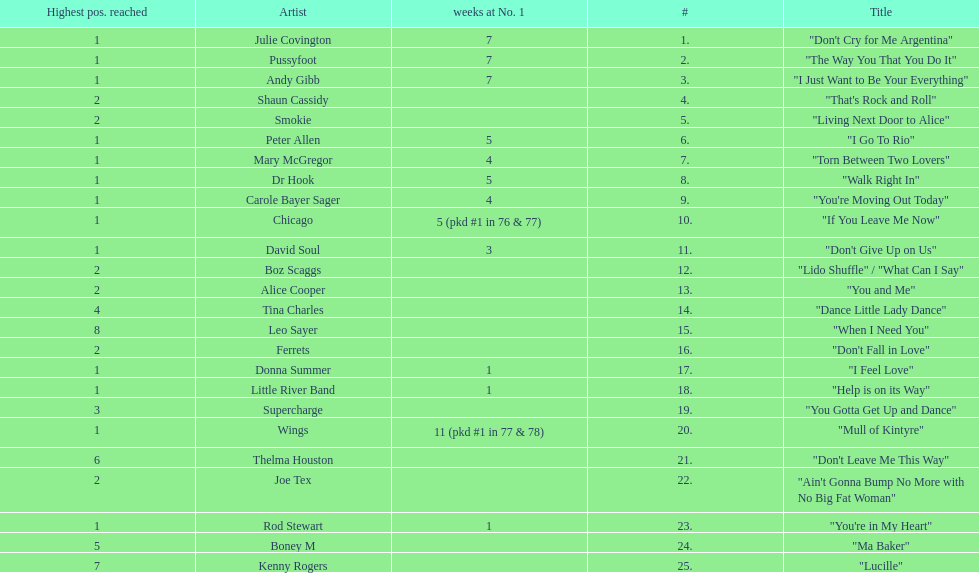How many weeks did julie covington's "don't cry for me argentina" spend at the top of australia's singles chart? 7. 